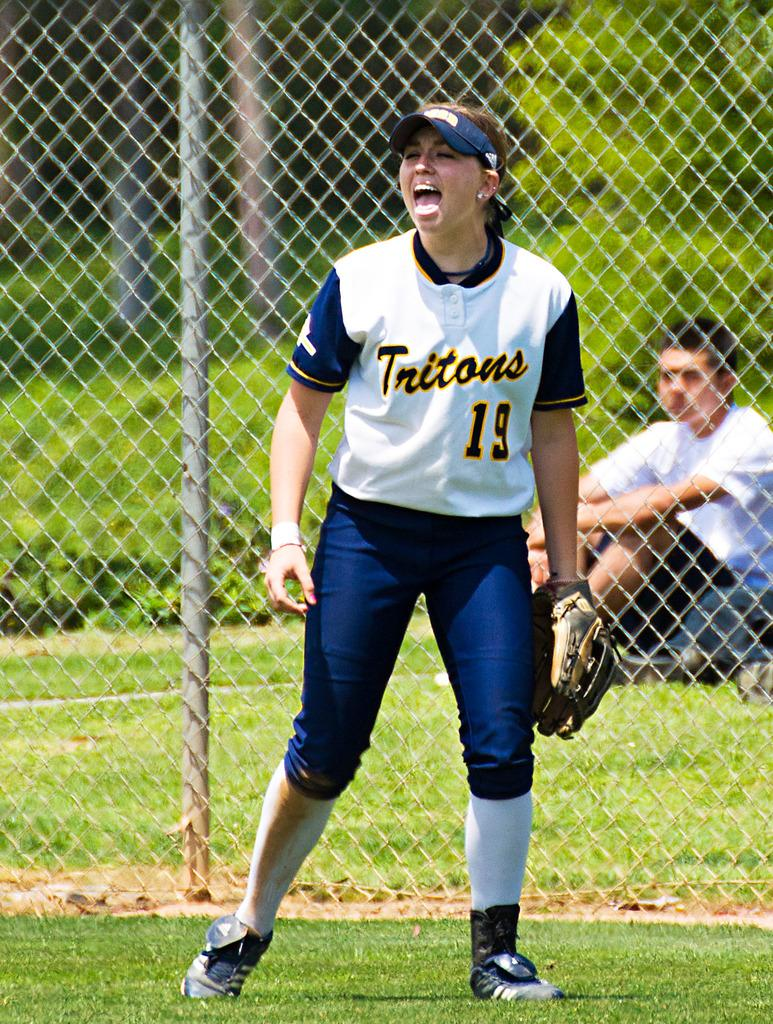Provide a one-sentence caption for the provided image. Player nineteen of the Tritons making a funny face. 